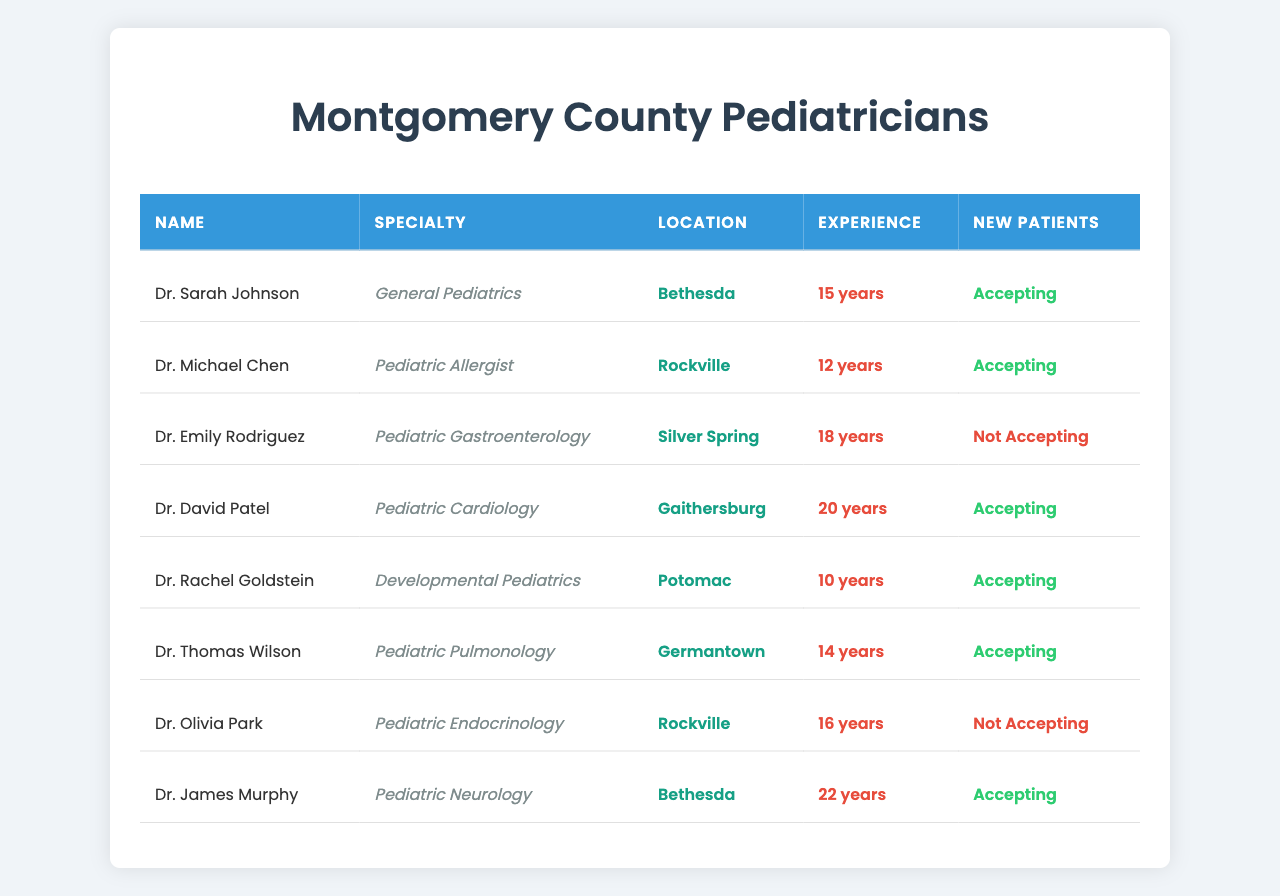What is the name of the pediatrician located in Bethesda? According to the table, there are two pediatricians located in Bethesda: Dr. Sarah Johnson and Dr. James Murphy.
Answer: Dr. Sarah Johnson and Dr. James Murphy Which pediatrician has the most years of experience? Dr. James Murphy has 22 years of experience, which is the highest compared to the others listed in the table.
Answer: Dr. James Murphy How many pediatricians are accepting new patients? From the table, the following pediatricians are accepting new patients: Dr. Sarah Johnson, Dr. Michael Chen, Dr. David Patel, Dr. Rachel Goldstein, and Dr. Thomas Wilson. That makes a total of 5.
Answer: 5 Are there any pediatricians specializing in Gastroenterology accepting new patients? The table shows that Dr. Emily Rodriguez specializes in Pediatric Gastroenterology and is not accepting new patients. Therefore, the answer is no.
Answer: No What is the average experience of the pediatricians who are accepting new patients? The experience of the pediatricians accepting new patients is: 15, 12, 20, 10, and 14 years. The average is (15 + 12 + 20 + 10 + 14) / 5 = 71 / 5 = 14.2 years.
Answer: 14.2 years Which location has the most pediatricians listed? The table includes two pediatricians in Rockville (Dr. Michael Chen and Dr. Olivia Park), while other locations such as Bethesda, Silver Spring, Gaithersburg, Potomac, and Germantown each have one pediatrician. This indicates Rockville has the most.
Answer: Rockville Is Dr. Thomas Wilson a Pediatric Allergist? The table specifies that Dr. Thomas Wilson's specialty is Pediatric Pulmonology, meaning he is not a Pediatric Allergist.
Answer: No What are the specialties of the pediatricians located in Rockville? The table indicates that there are two pediatricians in Rockville: Dr. Michael Chen, who specializes in Pediatric Allergist, and Dr. Olivia Park, who specializes in Pediatric Endocrinology.
Answer: Pediatric Allergist and Pediatric Endocrinology Which pediatrician has the least experience and is accepting new patients? Dr. Rachel Goldstein has 10 years of experience and is accepting new patients, which is less than others accepting new patients.
Answer: Dr. Rachel Goldstein What percentage of pediatricians in the table are not accepting new patients? There are 2 out of 8 pediatricians not accepting new patients. The percentage is (2 / 8) * 100 = 25%.
Answer: 25% 